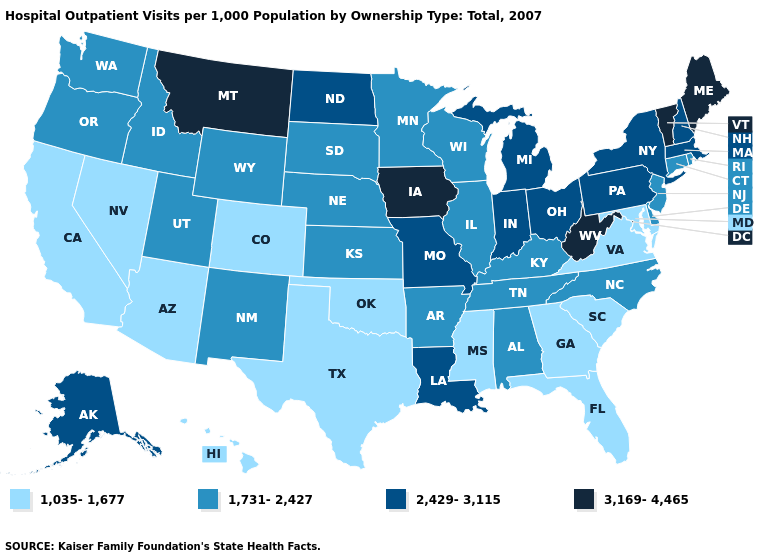Does Vermont have the highest value in the USA?
Concise answer only. Yes. Which states hav the highest value in the MidWest?
Be succinct. Iowa. Does Maryland have the lowest value in the USA?
Concise answer only. Yes. Among the states that border Connecticut , which have the highest value?
Keep it brief. Massachusetts, New York. Which states have the lowest value in the West?
Write a very short answer. Arizona, California, Colorado, Hawaii, Nevada. What is the lowest value in the USA?
Concise answer only. 1,035-1,677. Which states have the lowest value in the USA?
Keep it brief. Arizona, California, Colorado, Florida, Georgia, Hawaii, Maryland, Mississippi, Nevada, Oklahoma, South Carolina, Texas, Virginia. Does Colorado have a higher value than New York?
Answer briefly. No. What is the highest value in states that border California?
Quick response, please. 1,731-2,427. Does Colorado have the lowest value in the USA?
Give a very brief answer. Yes. What is the value of Montana?
Give a very brief answer. 3,169-4,465. Name the states that have a value in the range 1,035-1,677?
Answer briefly. Arizona, California, Colorado, Florida, Georgia, Hawaii, Maryland, Mississippi, Nevada, Oklahoma, South Carolina, Texas, Virginia. Which states hav the highest value in the Northeast?
Keep it brief. Maine, Vermont. What is the value of New York?
Quick response, please. 2,429-3,115. Does Massachusetts have the lowest value in the Northeast?
Concise answer only. No. 